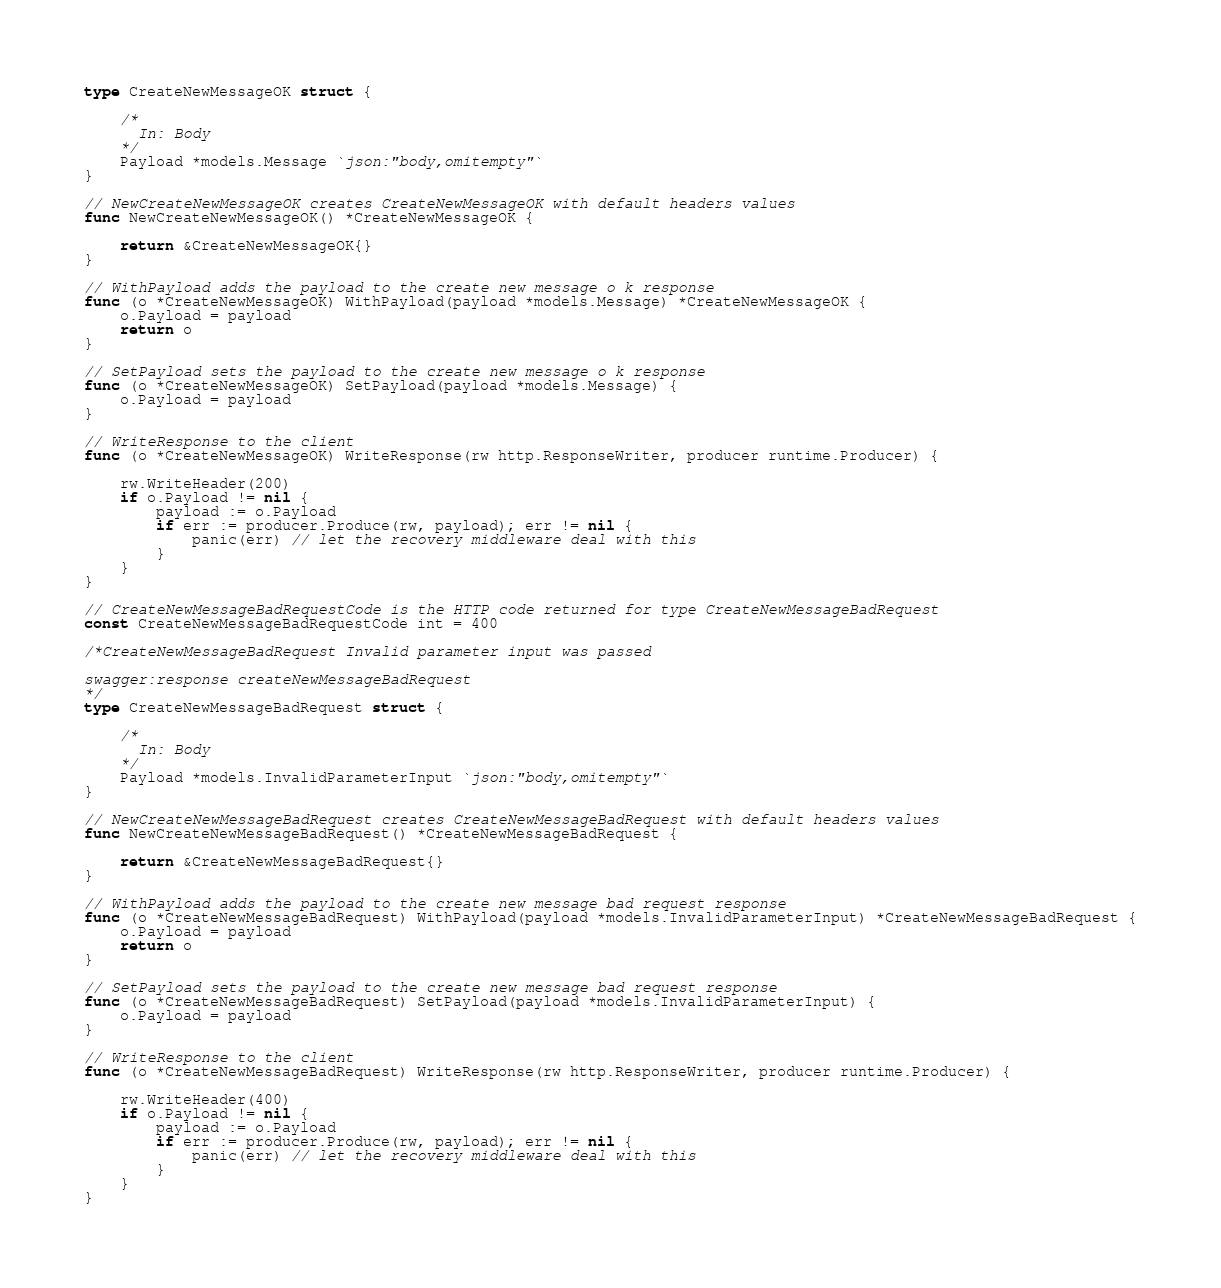<code> <loc_0><loc_0><loc_500><loc_500><_Go_>type CreateNewMessageOK struct {

	/*
	  In: Body
	*/
	Payload *models.Message `json:"body,omitempty"`
}

// NewCreateNewMessageOK creates CreateNewMessageOK with default headers values
func NewCreateNewMessageOK() *CreateNewMessageOK {

	return &CreateNewMessageOK{}
}

// WithPayload adds the payload to the create new message o k response
func (o *CreateNewMessageOK) WithPayload(payload *models.Message) *CreateNewMessageOK {
	o.Payload = payload
	return o
}

// SetPayload sets the payload to the create new message o k response
func (o *CreateNewMessageOK) SetPayload(payload *models.Message) {
	o.Payload = payload
}

// WriteResponse to the client
func (o *CreateNewMessageOK) WriteResponse(rw http.ResponseWriter, producer runtime.Producer) {

	rw.WriteHeader(200)
	if o.Payload != nil {
		payload := o.Payload
		if err := producer.Produce(rw, payload); err != nil {
			panic(err) // let the recovery middleware deal with this
		}
	}
}

// CreateNewMessageBadRequestCode is the HTTP code returned for type CreateNewMessageBadRequest
const CreateNewMessageBadRequestCode int = 400

/*CreateNewMessageBadRequest Invalid parameter input was passed

swagger:response createNewMessageBadRequest
*/
type CreateNewMessageBadRequest struct {

	/*
	  In: Body
	*/
	Payload *models.InvalidParameterInput `json:"body,omitempty"`
}

// NewCreateNewMessageBadRequest creates CreateNewMessageBadRequest with default headers values
func NewCreateNewMessageBadRequest() *CreateNewMessageBadRequest {

	return &CreateNewMessageBadRequest{}
}

// WithPayload adds the payload to the create new message bad request response
func (o *CreateNewMessageBadRequest) WithPayload(payload *models.InvalidParameterInput) *CreateNewMessageBadRequest {
	o.Payload = payload
	return o
}

// SetPayload sets the payload to the create new message bad request response
func (o *CreateNewMessageBadRequest) SetPayload(payload *models.InvalidParameterInput) {
	o.Payload = payload
}

// WriteResponse to the client
func (o *CreateNewMessageBadRequest) WriteResponse(rw http.ResponseWriter, producer runtime.Producer) {

	rw.WriteHeader(400)
	if o.Payload != nil {
		payload := o.Payload
		if err := producer.Produce(rw, payload); err != nil {
			panic(err) // let the recovery middleware deal with this
		}
	}
}
</code> 